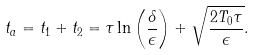Convert formula to latex. <formula><loc_0><loc_0><loc_500><loc_500>t _ { a } = t _ { 1 } + t _ { 2 } = \tau \ln \left ( \frac { \delta } { \epsilon } \right ) + \sqrt { \frac { 2 T _ { 0 } \tau } { \epsilon } } .</formula> 